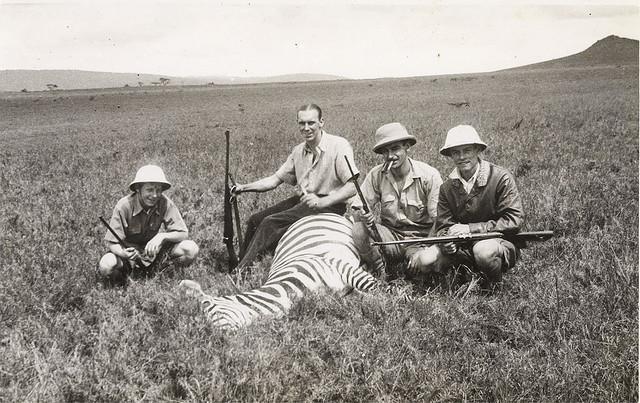How many people can be seen?
Give a very brief answer. 4. 